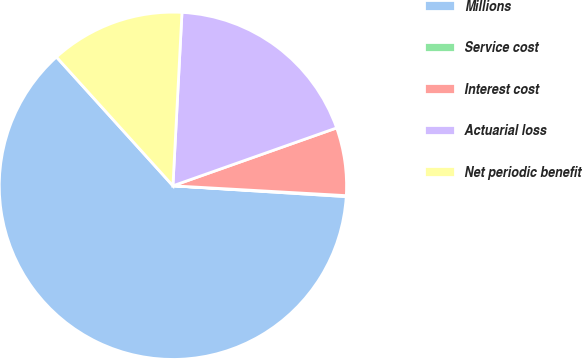<chart> <loc_0><loc_0><loc_500><loc_500><pie_chart><fcel>Millions<fcel>Service cost<fcel>Interest cost<fcel>Actuarial loss<fcel>Net periodic benefit<nl><fcel>62.3%<fcel>0.09%<fcel>6.31%<fcel>18.76%<fcel>12.53%<nl></chart> 